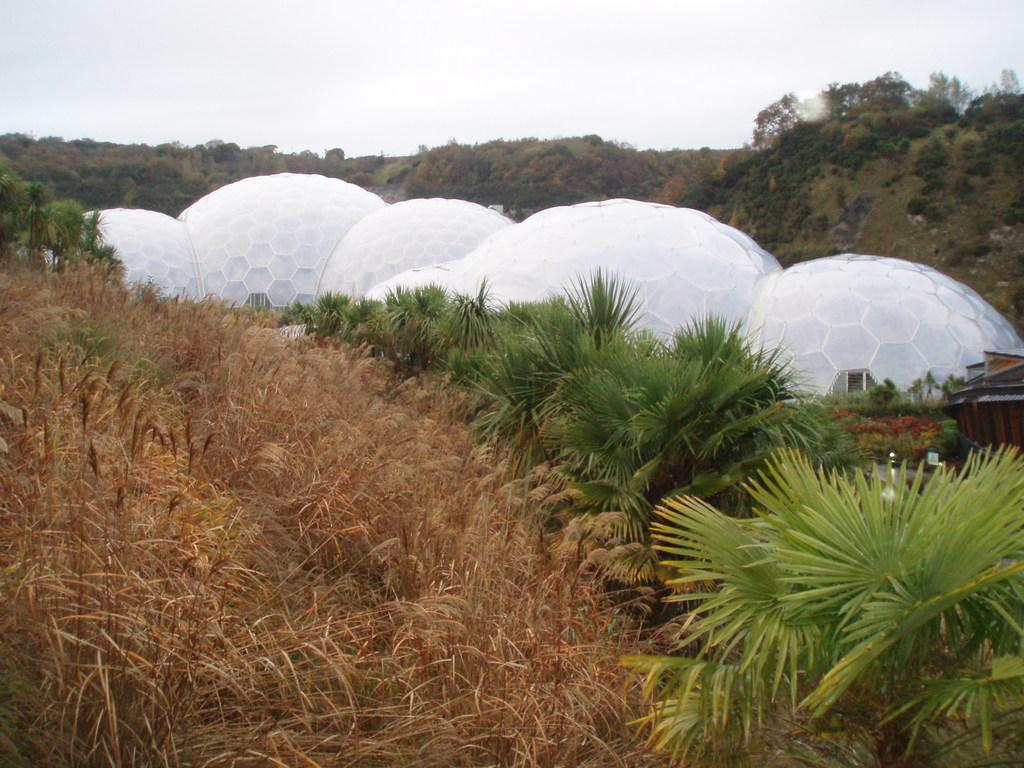What type of vegetation can be seen in the image? There is a group of trees and grass in the image. What structures are present in the center of the image? There is a group of sheds in the center of the image. What can be seen in the background of the image? Mountains and the sky are visible in the background of the image. What type of quiver is hanging on the trees in the image? There is no quiver present in the image; it features a group of trees, grass, sheds, mountains, and the sky. What type of cloth is draped over the sheds in the image? There is no cloth draped over the sheds in the image; only the sheds themselves are visible. 